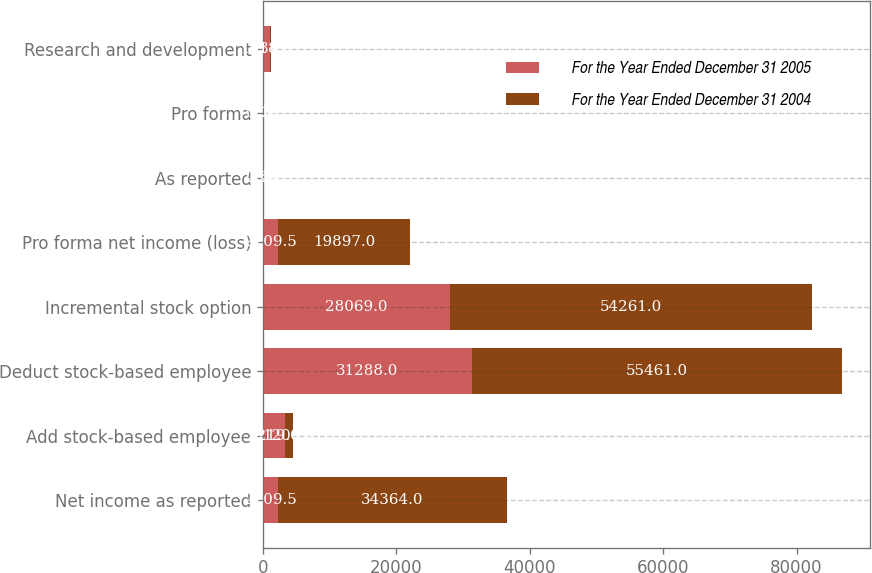Convert chart to OTSL. <chart><loc_0><loc_0><loc_500><loc_500><stacked_bar_chart><ecel><fcel>Net income as reported<fcel>Add stock-based employee<fcel>Deduct stock-based employee<fcel>Incremental stock option<fcel>Pro forma net income (loss)<fcel>As reported<fcel>Pro forma<fcel>Research and development<nl><fcel>For the Year Ended December 31 2005<fcel>2209.5<fcel>3219<fcel>31288<fcel>28069<fcel>2209.5<fcel>2.41<fcel>2.2<fcel>1034<nl><fcel>For the Year Ended December 31 2004<fcel>34364<fcel>1200<fcel>55461<fcel>54261<fcel>19897<fcel>0.28<fcel>0.16<fcel>118<nl></chart> 